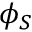<formula> <loc_0><loc_0><loc_500><loc_500>\phi _ { S }</formula> 